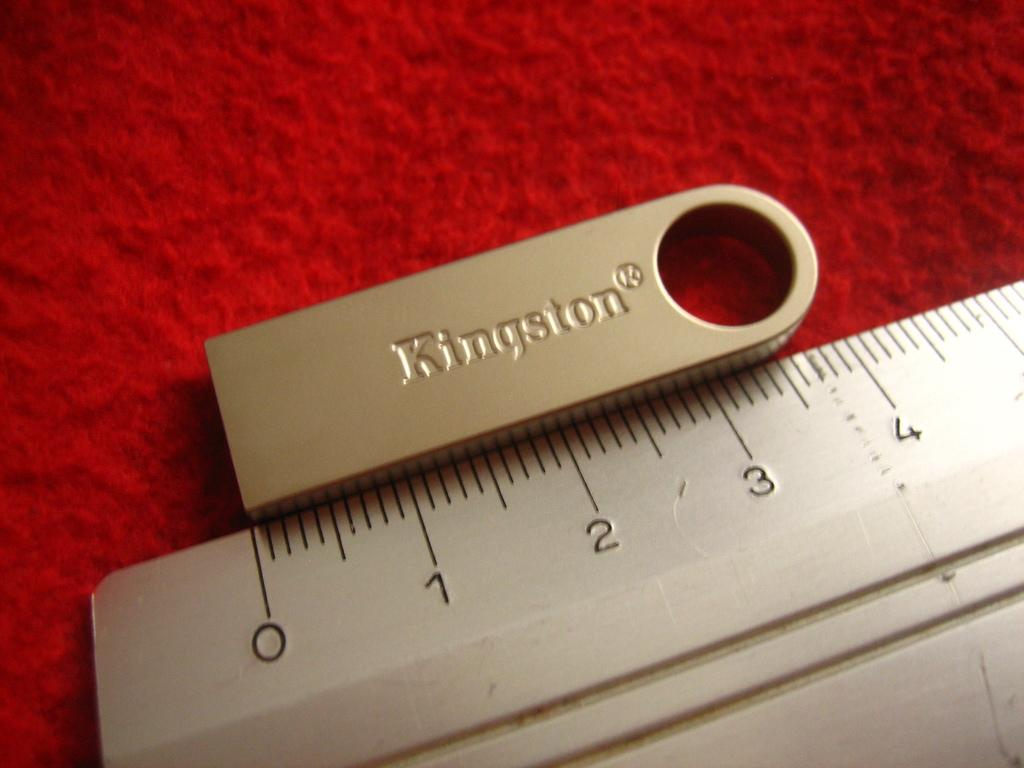<image>
Provide a brief description of the given image. kingston accessory and meaning ruler sits on the counter 